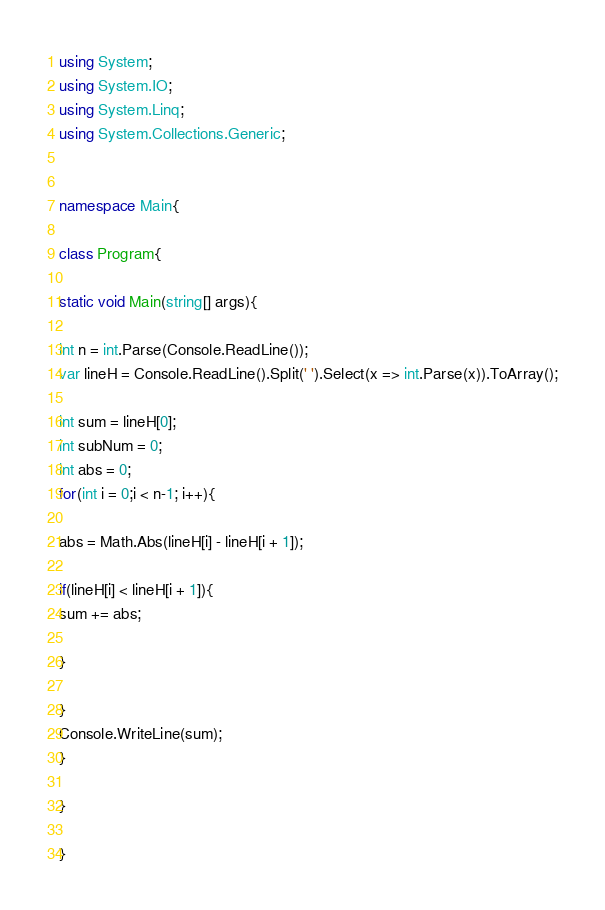Convert code to text. <code><loc_0><loc_0><loc_500><loc_500><_C#_>using System;
using System.IO;
using System.Linq;
using System.Collections.Generic;


namespace Main{

class Program{

static void Main(string[] args){

int n = int.Parse(Console.ReadLine());
var lineH = Console.ReadLine().Split(' ').Select(x => int.Parse(x)).ToArray();

int sum = lineH[0];
int subNum = 0;
int abs = 0;
for(int i = 0;i < n-1; i++){

abs = Math.Abs(lineH[i] - lineH[i + 1]);

if(lineH[i] < lineH[i + 1]){
sum += abs;

}

}
Console.WriteLine(sum);
}

}

}</code> 